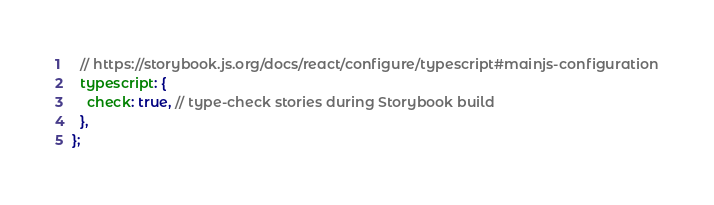Convert code to text. <code><loc_0><loc_0><loc_500><loc_500><_JavaScript_>  // https://storybook.js.org/docs/react/configure/typescript#mainjs-configuration
  typescript: {
    check: true, // type-check stories during Storybook build
  },
};
</code> 